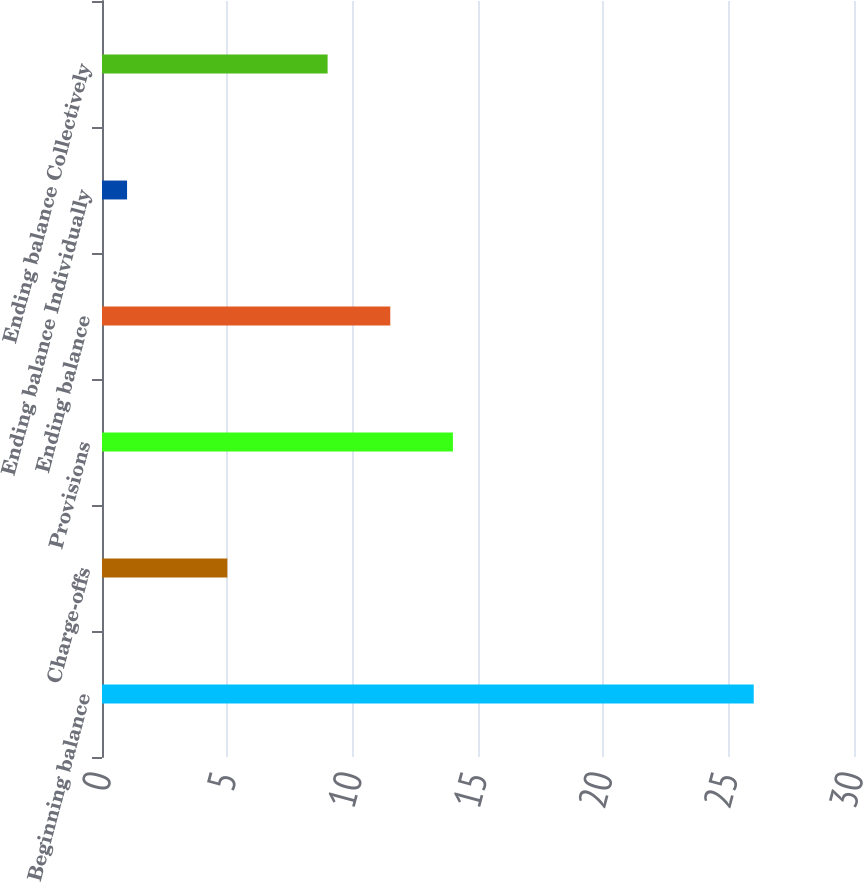Convert chart. <chart><loc_0><loc_0><loc_500><loc_500><bar_chart><fcel>Beginning balance<fcel>Charge-offs<fcel>Provisions<fcel>Ending balance<fcel>Ending balance Individually<fcel>Ending balance Collectively<nl><fcel>26<fcel>5<fcel>14<fcel>11.5<fcel>1<fcel>9<nl></chart> 